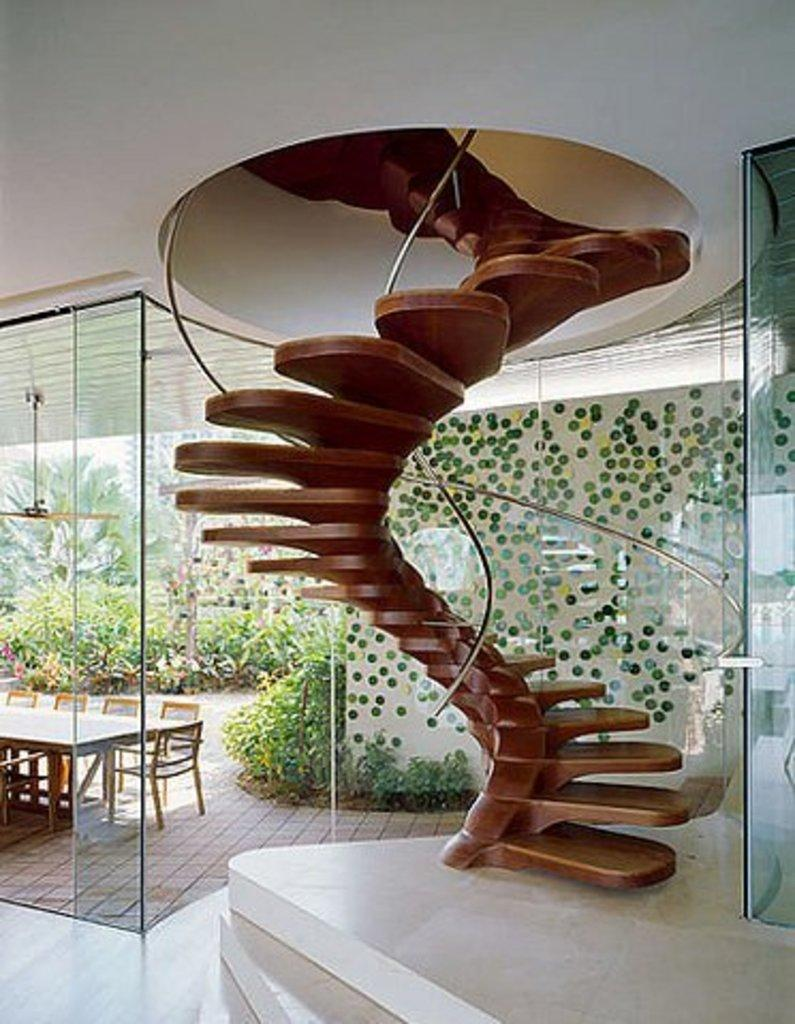What type of structure is present in the image? There is a staircase in the image. What type of doors can be seen in the image? There are glass doors in the image. What type of furniture is present in the image? There is a table and chairs in the image. What type of greenery is present in the image? There are plants and trees in the image. What is visible in the background of the image? There is a building in the background of the image. What type of glue is being used to hold the trees together in the image? There is no glue present in the image, and the trees are not being held together. What type of quince is being served on the table in the image? There is no quince present in the image; it only shows a table, chairs, and plants. 